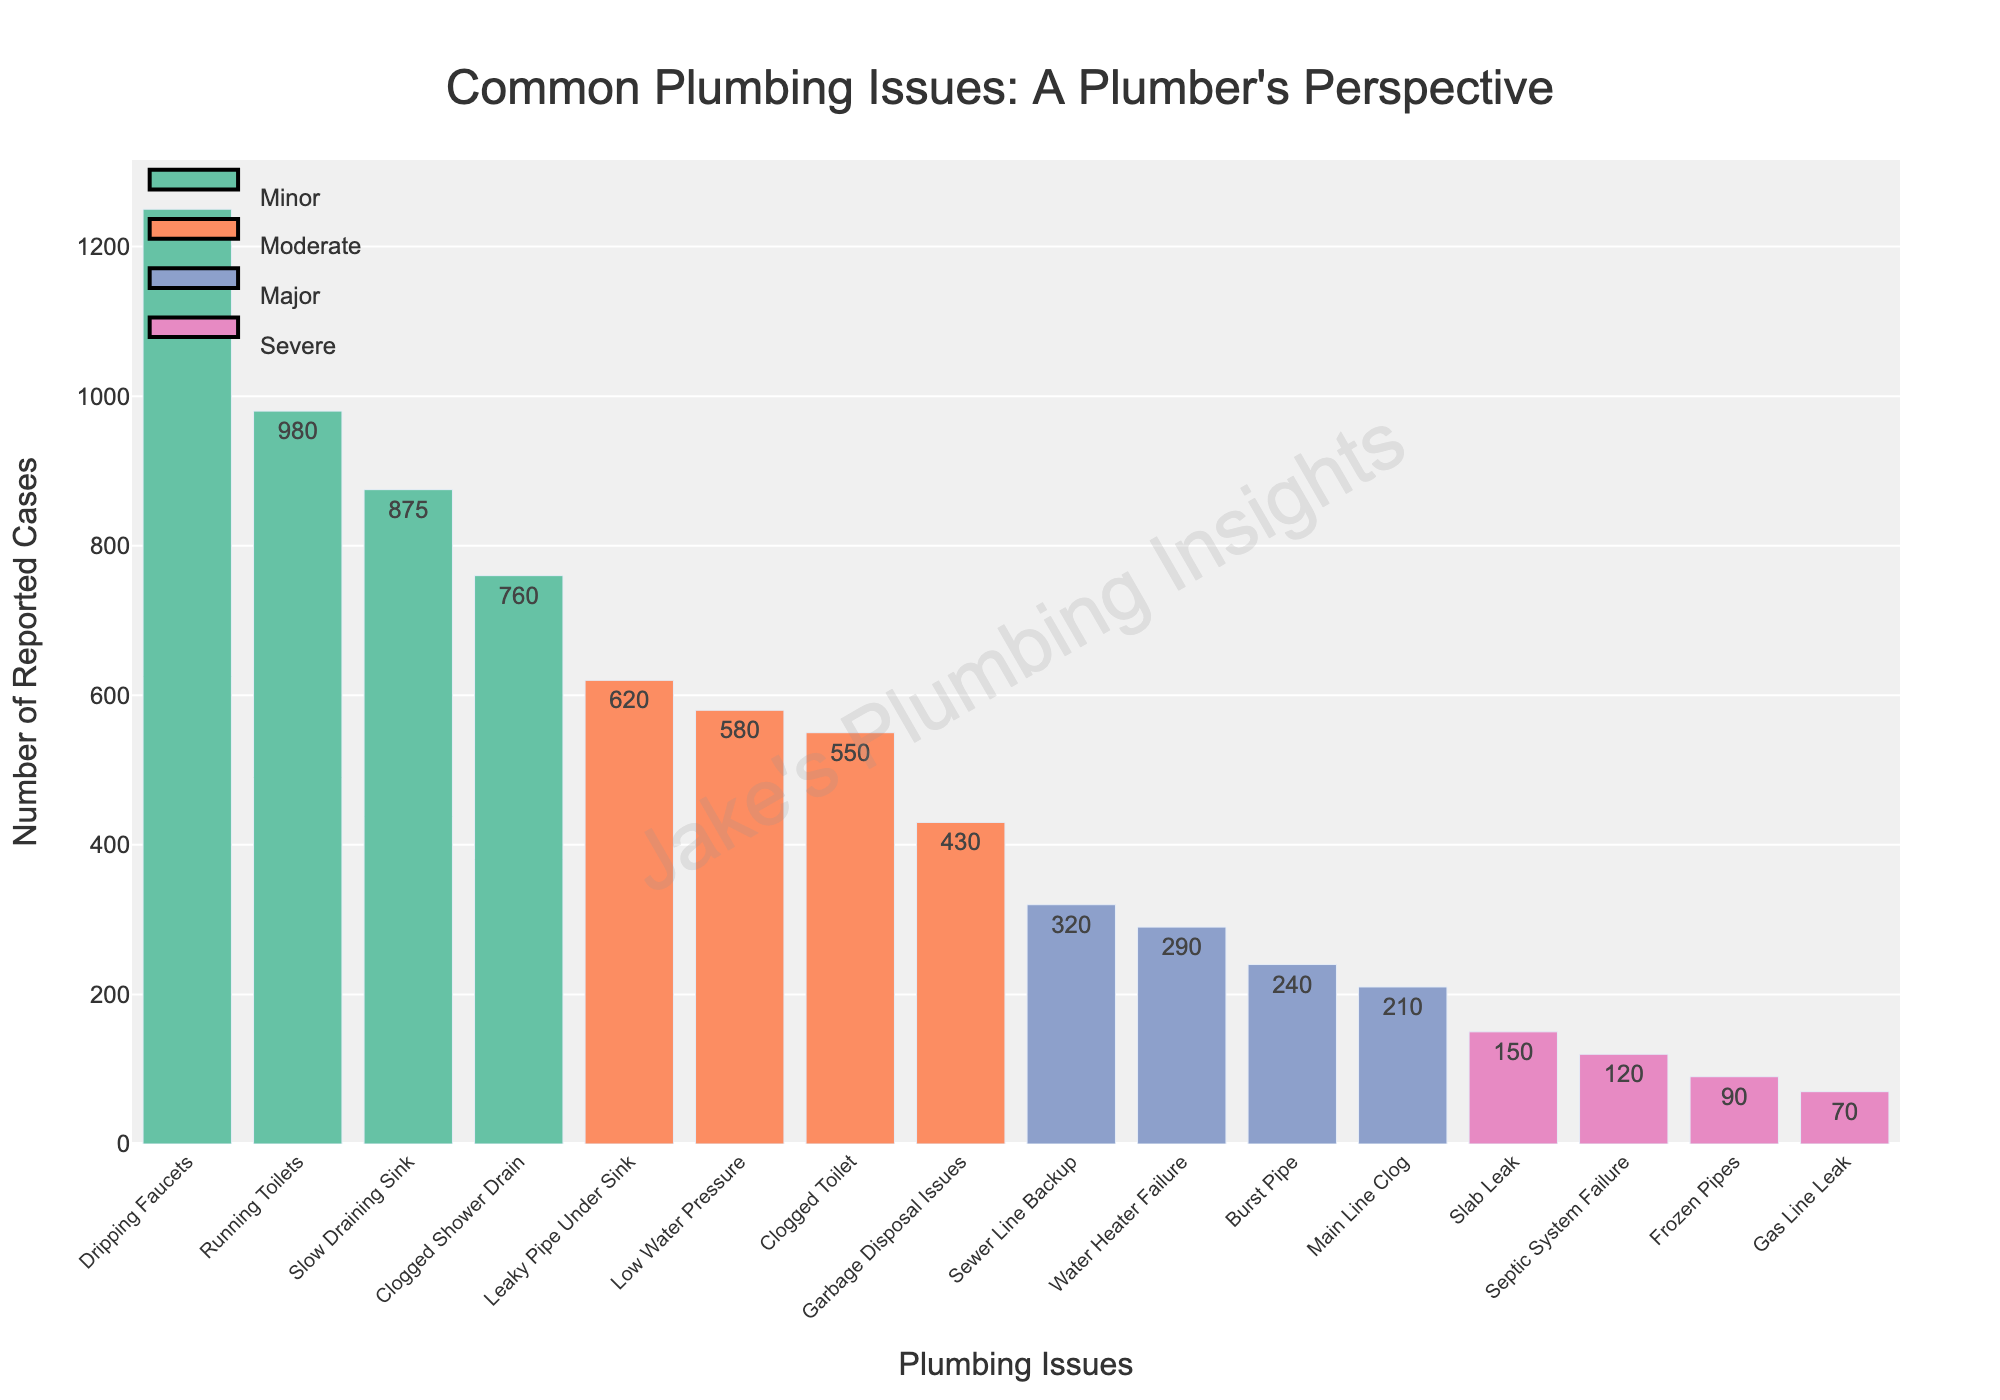Which plumbing issue has the highest number of reported cases? The bar with the highest length represents the issue with the highest number of reported cases, which is "Dripping Faucets" with 1250 cases.
Answer: Dripping Faucets How many more cases of dripping faucets are there compared to running toilets? The cases for dripping faucets are 1250, and for running toilets, it's 980. The difference is 1250 - 980 = 270.
Answer: 270 Which severity has the most reported issues in total? By summing the reported cases for each severity: Minor (1250 + 980 + 875 + 760 = 3865), Moderate (620 + 580 + 550 + 430 = 2180), Major (320 + 290 + 240 + 210 = 1060), Severe (150 + 120 + 90 + 70 = 430). Minor has the most with 3865 cases.
Answer: Minor What is the second most severe issue in terms of reported cases? The severe category consists of slab leak (150), septic system failure (120), frozen pipes (90), and gas line leak (70). The second most cases are for septic system failure with 120 reported cases.
Answer: Septic System Failure Compare the number of reported cases for minor and major issues altogether. Total Minor cases are 3865, and Major cases are 1060. Comparing 3865 to 1060 shows that Minor issues are far more frequent than Major issues.
Answer: Minor issues How many more minor cases are reported compared to severe cases? The total reported minor cases are 3865, and for severe cases, it's 430. The difference is 3865 - 430 = 3435.
Answer: 3435 Which plumbing issue in the major severity category has the least reported cases? The major issues listed are sewer line backup (320), water heater failure (290), burst pipe (240), and main line clog (210). The issue with the least cases is "Main Line Clog" with 210 cases.
Answer: Main Line Clog Rank the moderate issues from most to least reported cases. The moderate issues are: Leaky Pipe Under Sink (620), Low Water Pressure (580), Clogged Toilet (550), and Garbage Disposal Issues (430). Ordered from most to least: 620, 580, 550, 430.
Answer: Leaky Pipe Under Sink > Low Water Pressure > Clogged Toilet > Garbage Disposal Issues Which issue has a higher number of reported cases, a leaky pipe under the sink or a clogged toilet? Leaky Pipe Under Sink has 620 cases, while Clogged Toilet has 550 cases. Leaky Pipe Under Sink has more reported cases.
Answer: Leaky Pipe Under Sink What is the total number of reported cases for severe issues? Summing the cases for slab leak (150), septic system failure (120), frozen pipes (90), and gas line leak (70) gives 150 + 120 + 90 + 70 = 430 cases.
Answer: 430 